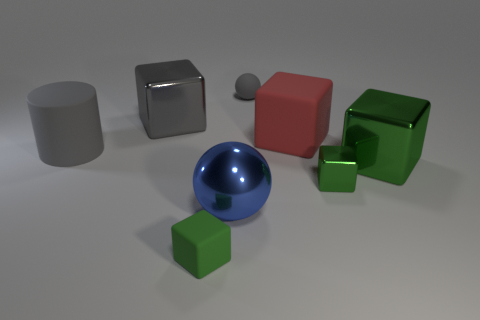Subtract all red spheres. How many green cubes are left? 3 Subtract all gray cubes. How many cubes are left? 4 Subtract all red matte cubes. How many cubes are left? 4 Subtract all blue balls. Subtract all brown cylinders. How many balls are left? 1 Add 1 balls. How many objects exist? 9 Subtract all balls. How many objects are left? 6 Add 4 metal cubes. How many metal cubes are left? 7 Add 8 large rubber things. How many large rubber things exist? 10 Subtract 1 blue spheres. How many objects are left? 7 Subtract all small green metallic things. Subtract all tiny green cubes. How many objects are left? 5 